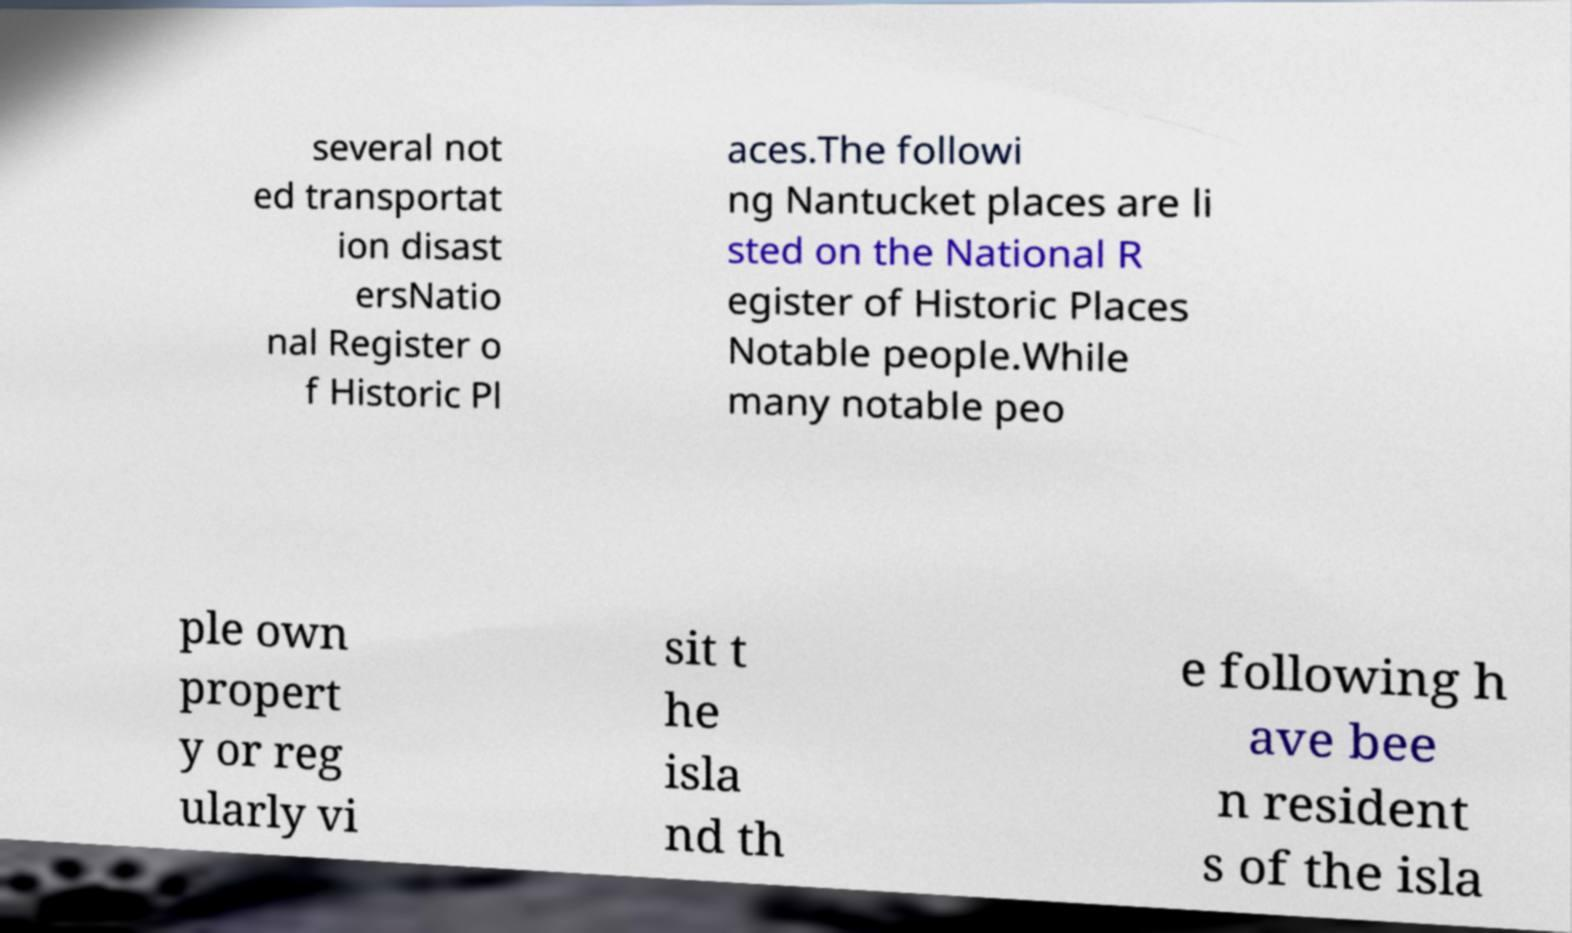Please read and relay the text visible in this image. What does it say? several not ed transportat ion disast ersNatio nal Register o f Historic Pl aces.The followi ng Nantucket places are li sted on the National R egister of Historic Places Notable people.While many notable peo ple own propert y or reg ularly vi sit t he isla nd th e following h ave bee n resident s of the isla 